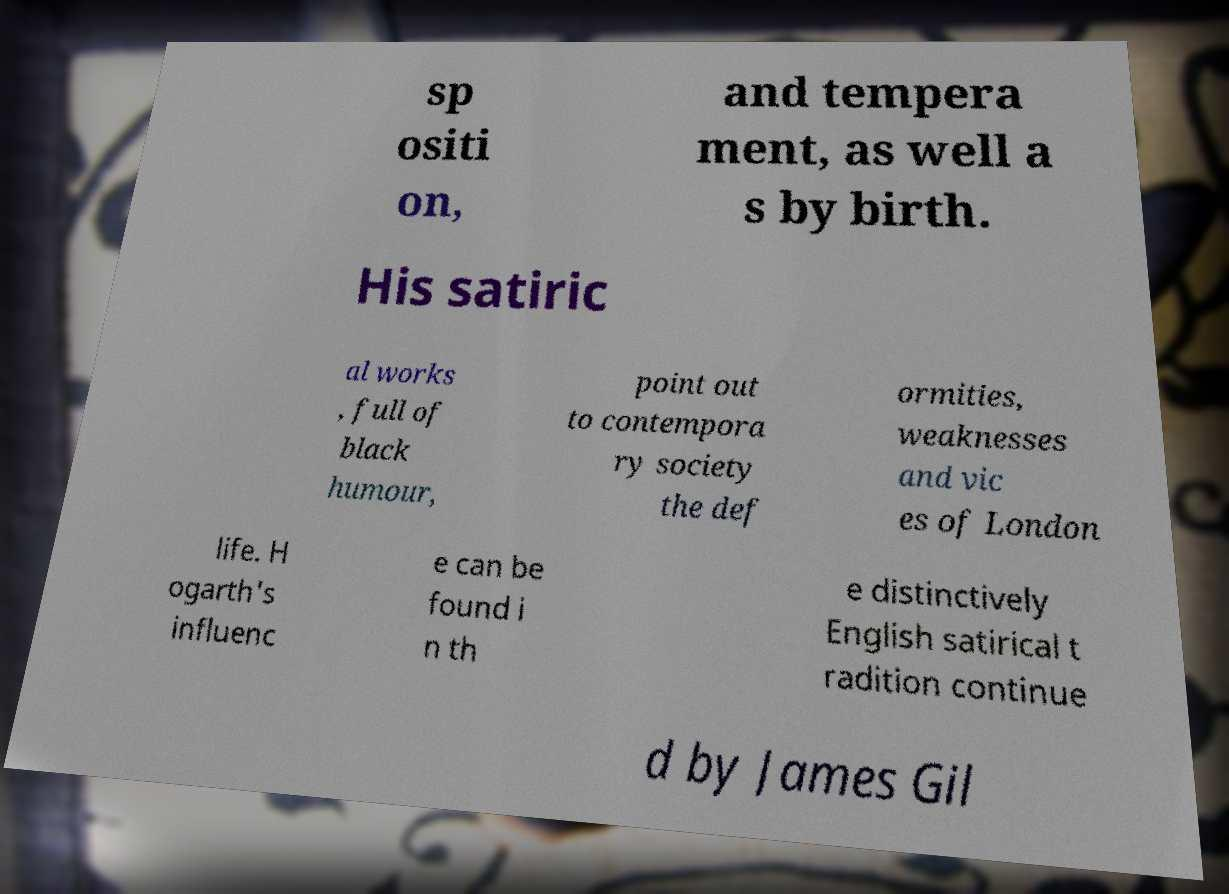There's text embedded in this image that I need extracted. Can you transcribe it verbatim? sp ositi on, and tempera ment, as well a s by birth. His satiric al works , full of black humour, point out to contempora ry society the def ormities, weaknesses and vic es of London life. H ogarth's influenc e can be found i n th e distinctively English satirical t radition continue d by James Gil 